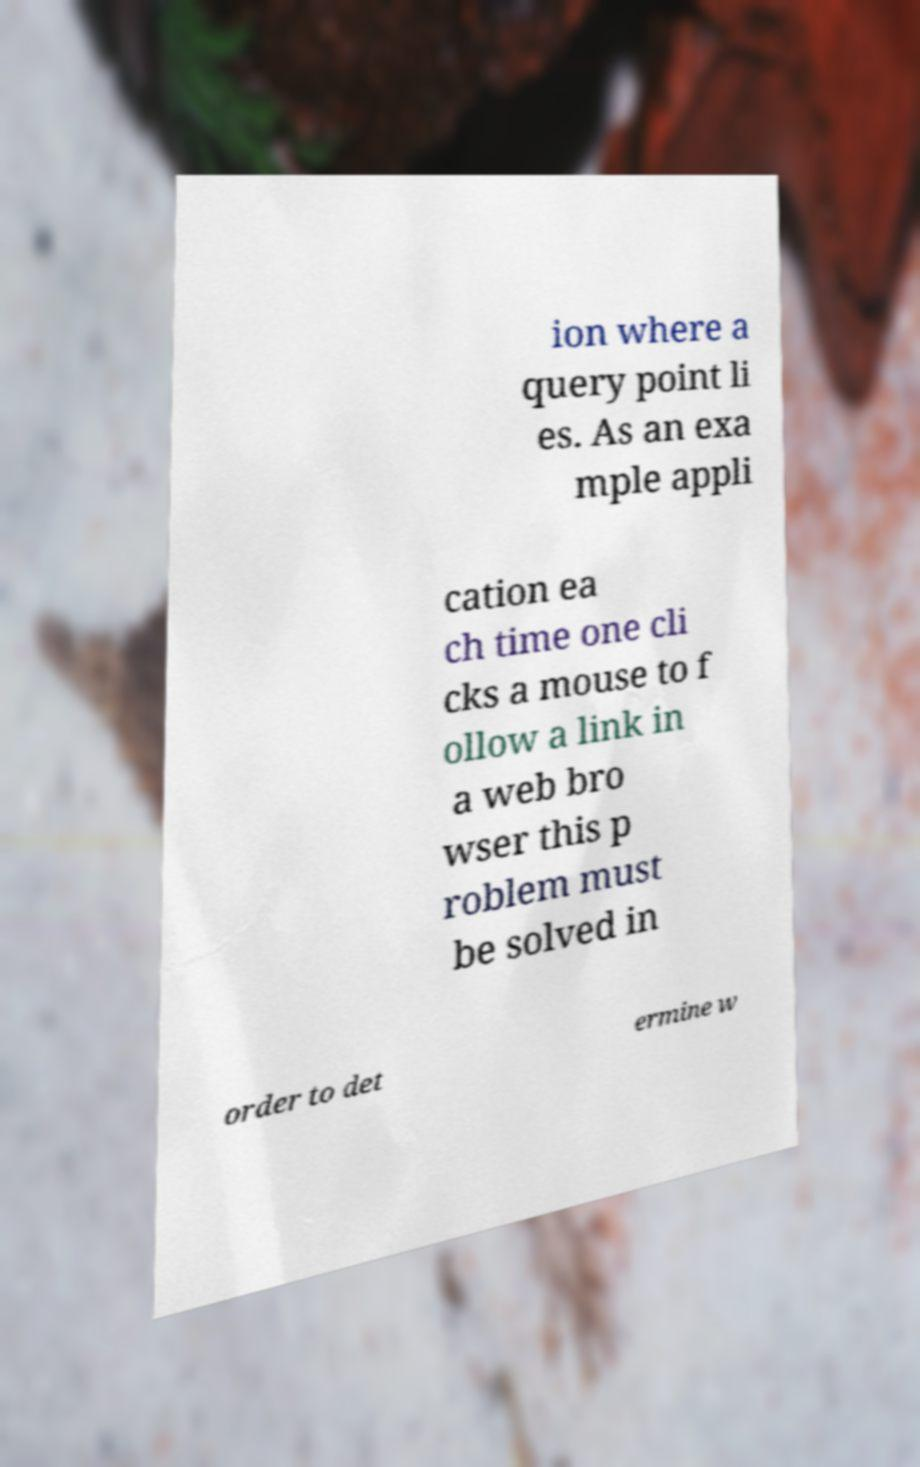I need the written content from this picture converted into text. Can you do that? ion where a query point li es. As an exa mple appli cation ea ch time one cli cks a mouse to f ollow a link in a web bro wser this p roblem must be solved in order to det ermine w 